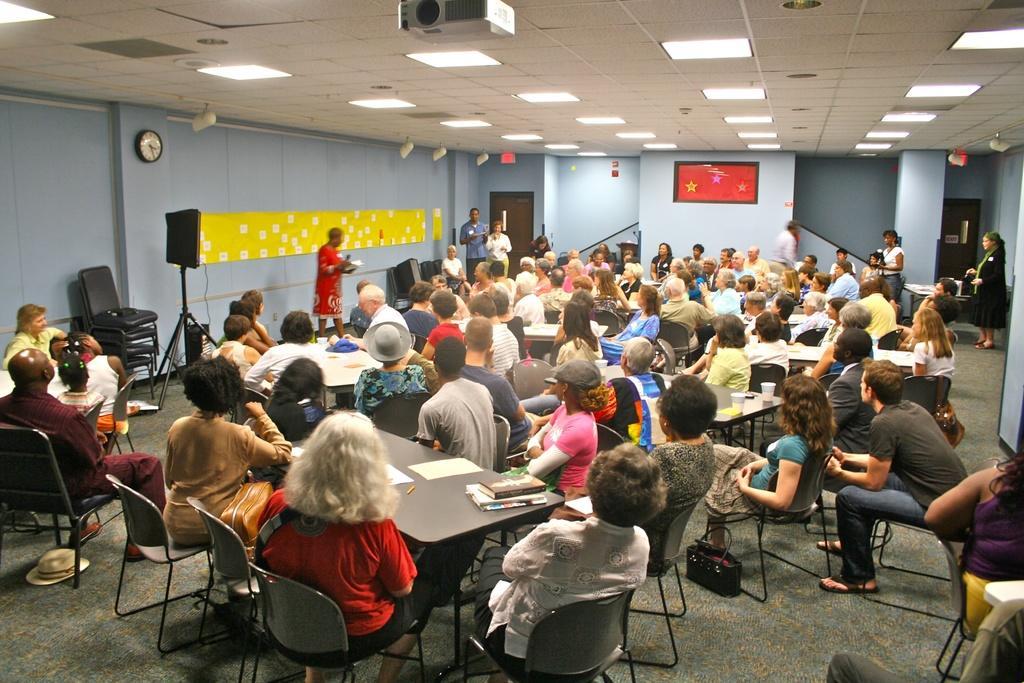Could you give a brief overview of what you see in this image? In this image it looks like there are group of people who are sitting and listening to the person who is in front of them. Its look like a meeting. In front of them there is a wall and speaker and chairs. At the top there is projector,ceiling and lights. On the table there are books and papers. 